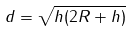<formula> <loc_0><loc_0><loc_500><loc_500>d = \sqrt { h ( 2 R + h ) }</formula> 